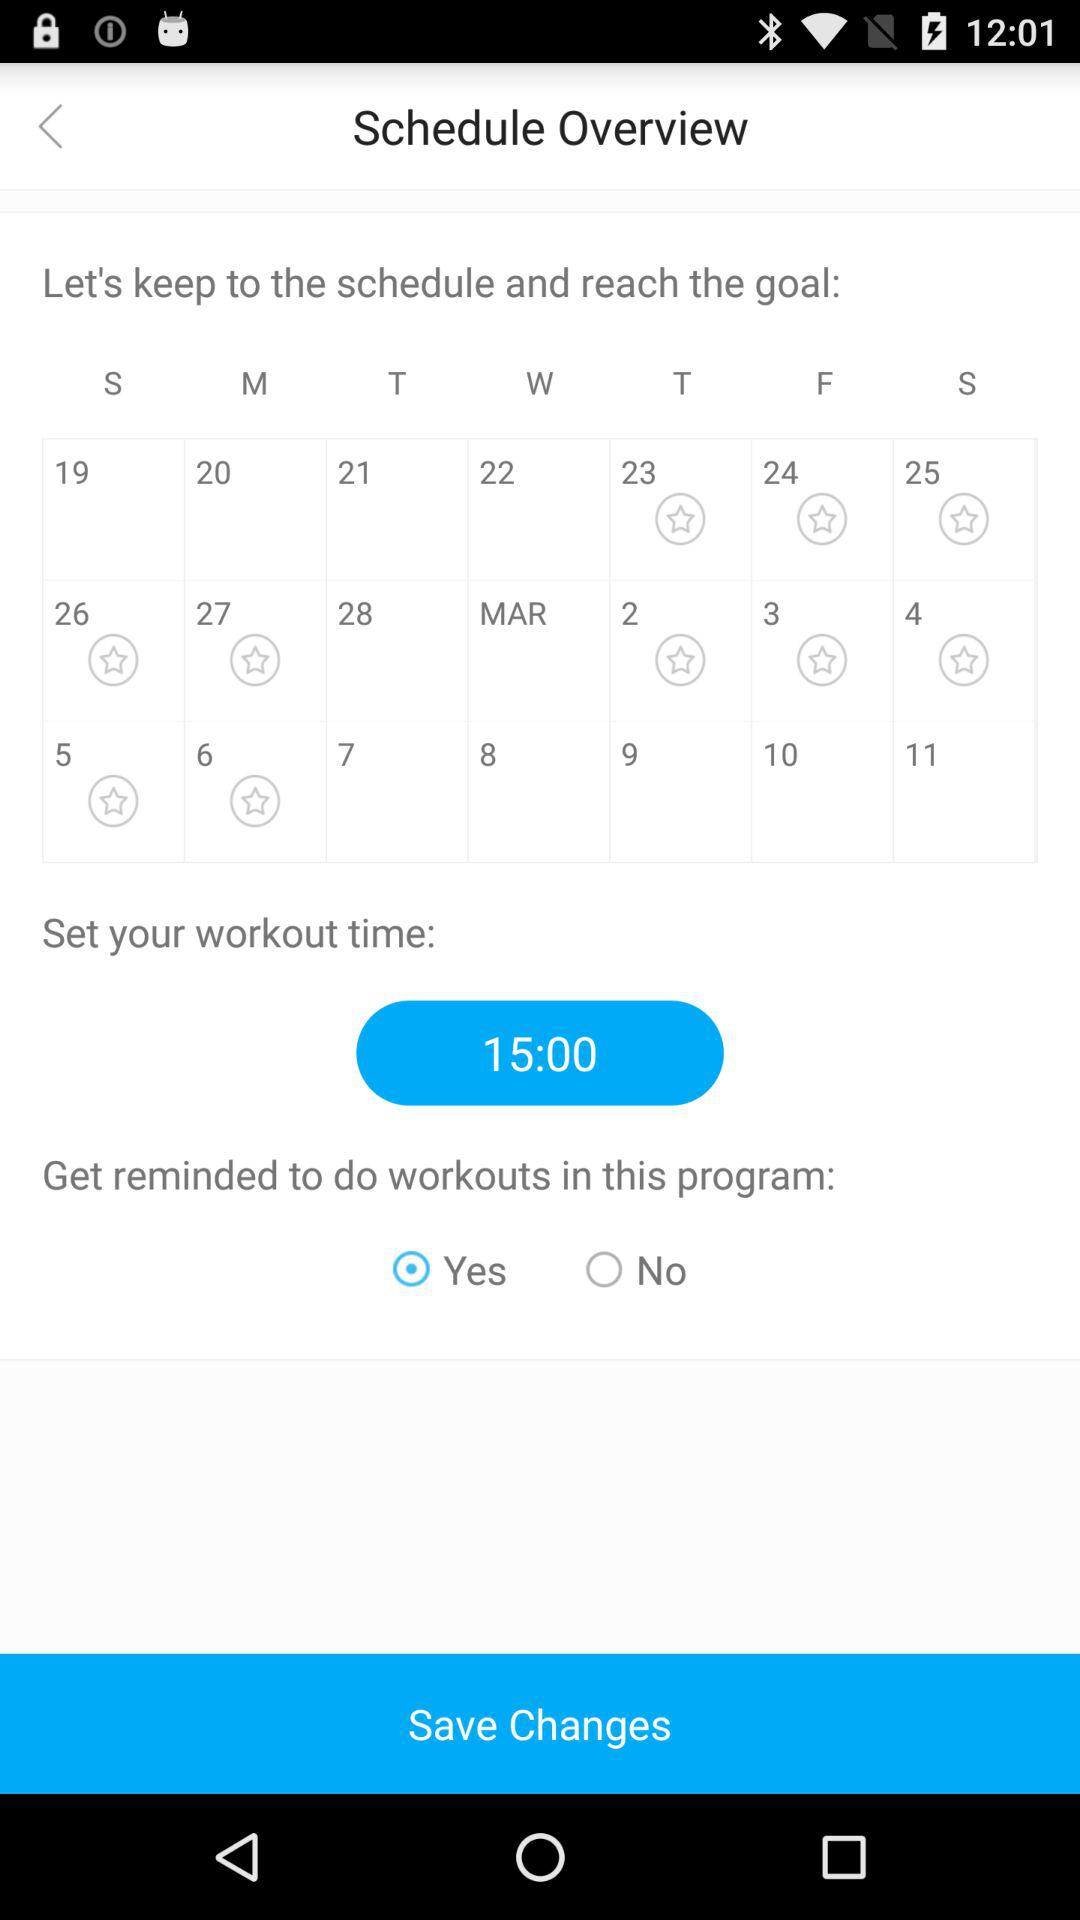What is the set workout time? The set workout time is 15:00. 